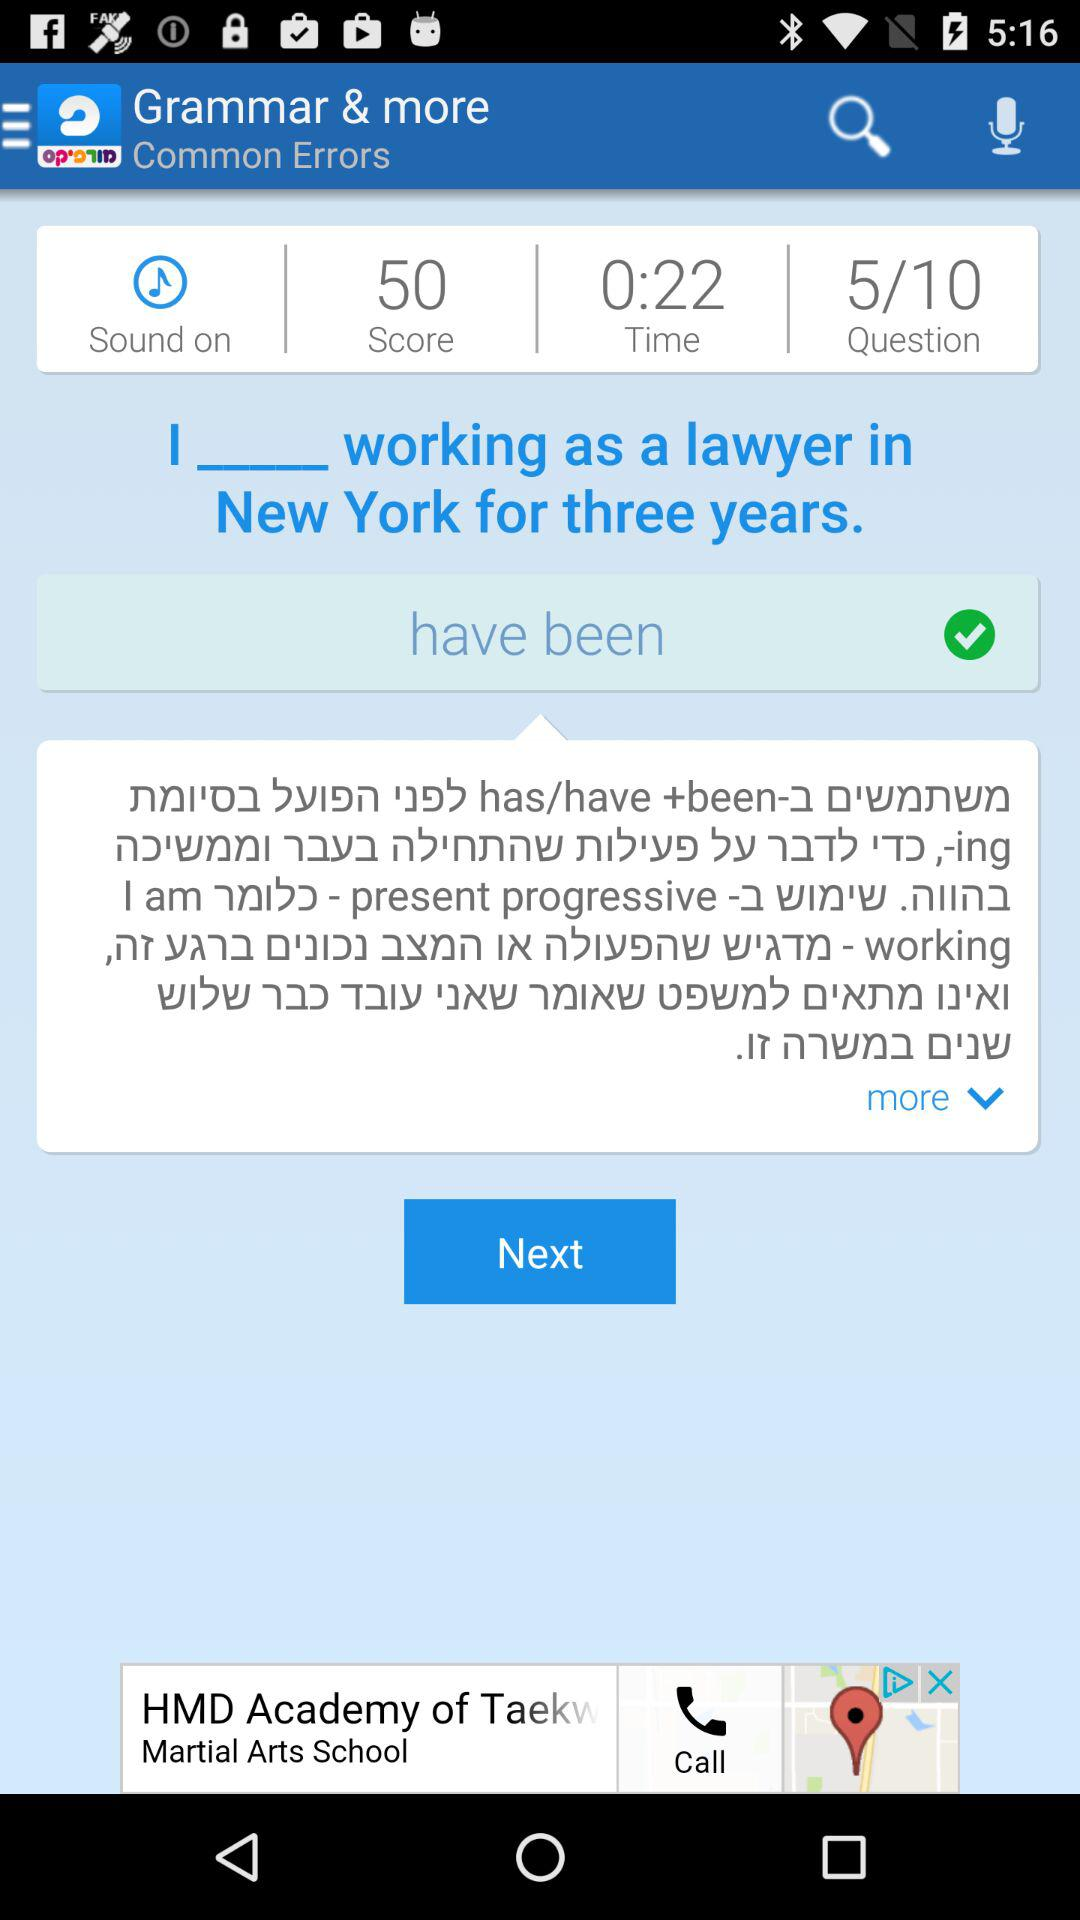What is the displayed response?
When the provided information is insufficient, respond with <no answer>. <no answer> 